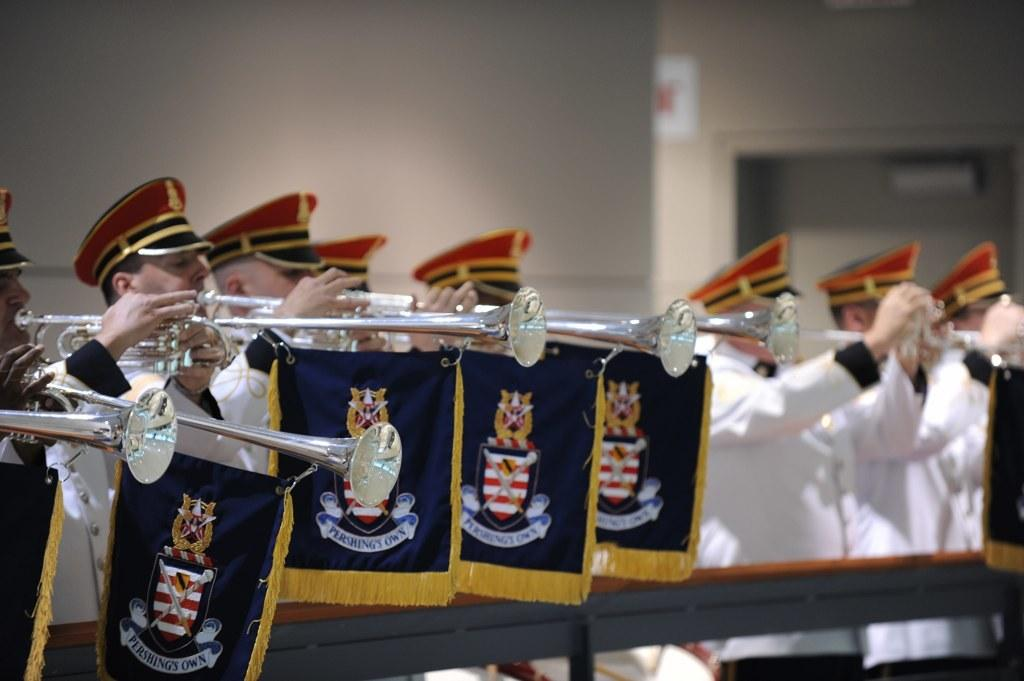What are the people in the image doing? The people in the image are playing musical instruments. What are the people wearing? The people are wearing white uniforms. What can be seen in the background of the image? The background wall is in cream color. Is there any flag visible in the image? Yes, there is a blue color flag in the image. How many times does the police officer twist the observation in the image? There is no police officer or observation present in the image. What type of twist can be seen in the image? There is no twist visible in the image. 